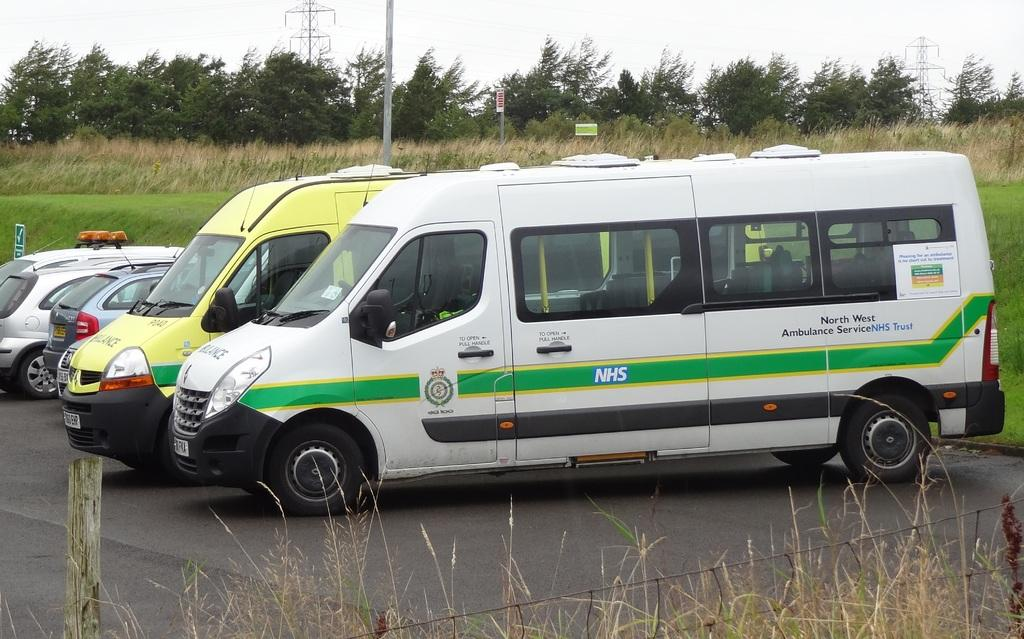<image>
Present a compact description of the photo's key features. a van with a pull handle sign on it 